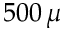Convert formula to latex. <formula><loc_0><loc_0><loc_500><loc_500>5 0 0 \, \mu</formula> 